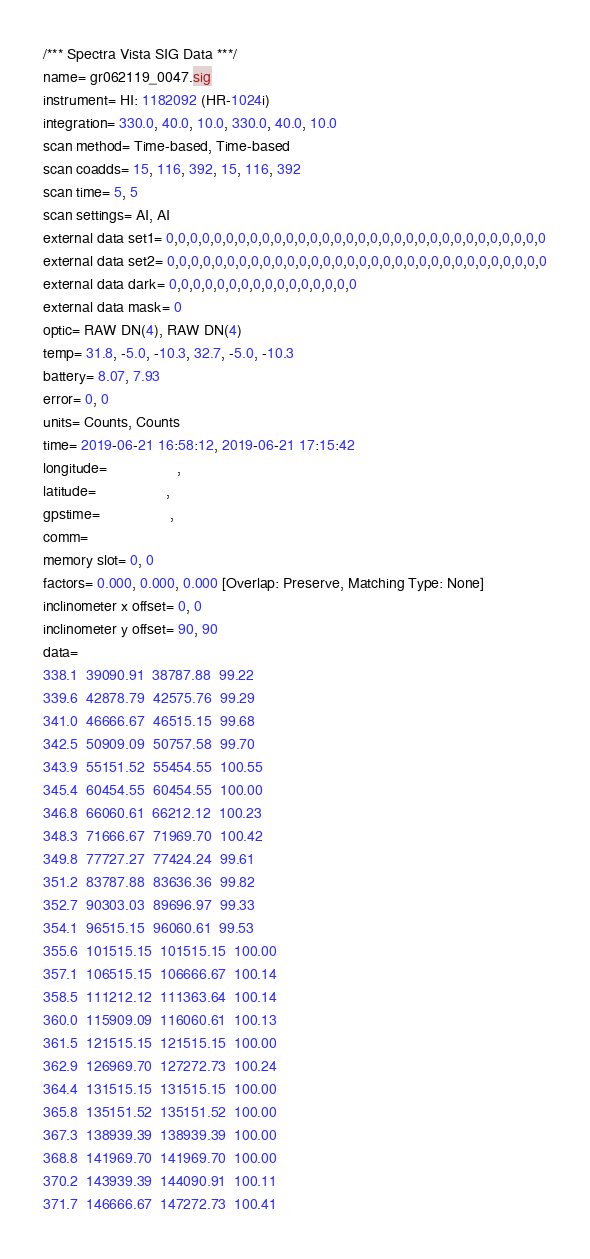Convert code to text. <code><loc_0><loc_0><loc_500><loc_500><_SML_>/*** Spectra Vista SIG Data ***/
name= gr062119_0047.sig
instrument= HI: 1182092 (HR-1024i)
integration= 330.0, 40.0, 10.0, 330.0, 40.0, 10.0
scan method= Time-based, Time-based
scan coadds= 15, 116, 392, 15, 116, 392
scan time= 5, 5
scan settings= AI, AI
external data set1= 0,0,0,0,0,0,0,0,0,0,0,0,0,0,0,0,0,0,0,0,0,0,0,0,0,0,0,0,0,0,0,0
external data set2= 0,0,0,0,0,0,0,0,0,0,0,0,0,0,0,0,0,0,0,0,0,0,0,0,0,0,0,0,0,0,0,0
external data dark= 0,0,0,0,0,0,0,0,0,0,0,0,0,0,0,0
external data mask= 0
optic= RAW DN(4), RAW DN(4)
temp= 31.8, -5.0, -10.3, 32.7, -5.0, -10.3
battery= 8.07, 7.93
error= 0, 0
units= Counts, Counts
time= 2019-06-21 16:58:12, 2019-06-21 17:15:42
longitude=                 ,                 
latitude=                 ,                 
gpstime=                 ,                 
comm= 
memory slot= 0, 0
factors= 0.000, 0.000, 0.000 [Overlap: Preserve, Matching Type: None]
inclinometer x offset= 0, 0
inclinometer y offset= 90, 90
data= 
338.1  39090.91  38787.88  99.22
339.6  42878.79  42575.76  99.29
341.0  46666.67  46515.15  99.68
342.5  50909.09  50757.58  99.70
343.9  55151.52  55454.55  100.55
345.4  60454.55  60454.55  100.00
346.8  66060.61  66212.12  100.23
348.3  71666.67  71969.70  100.42
349.8  77727.27  77424.24  99.61
351.2  83787.88  83636.36  99.82
352.7  90303.03  89696.97  99.33
354.1  96515.15  96060.61  99.53
355.6  101515.15  101515.15  100.00
357.1  106515.15  106666.67  100.14
358.5  111212.12  111363.64  100.14
360.0  115909.09  116060.61  100.13
361.5  121515.15  121515.15  100.00
362.9  126969.70  127272.73  100.24
364.4  131515.15  131515.15  100.00
365.8  135151.52  135151.52  100.00
367.3  138939.39  138939.39  100.00
368.8  141969.70  141969.70  100.00
370.2  143939.39  144090.91  100.11
371.7  146666.67  147272.73  100.41</code> 